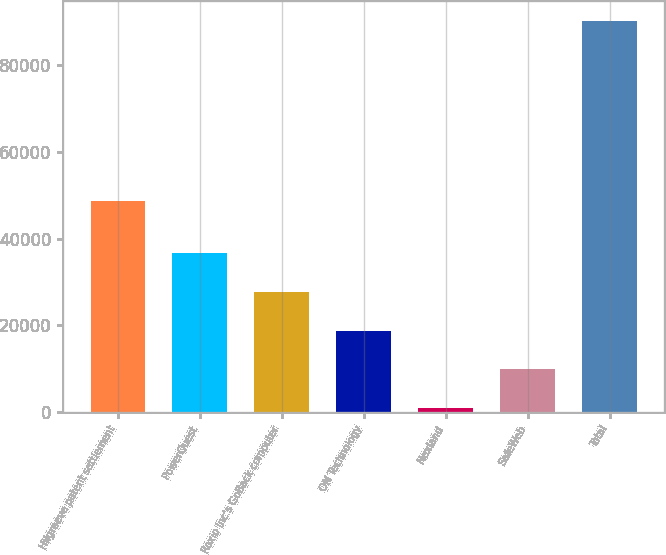Convert chart to OTSL. <chart><loc_0><loc_0><loc_500><loc_500><bar_chart><fcel>Hilgraeve patent settlement<fcel>PowerQuest<fcel>Roxio Inc's GoBack computer<fcel>ON Technology<fcel>Nexland<fcel>SafeWeb<fcel>Total<nl><fcel>48583<fcel>36670.4<fcel>27752.8<fcel>18835.2<fcel>1000<fcel>9917.6<fcel>90176<nl></chart> 